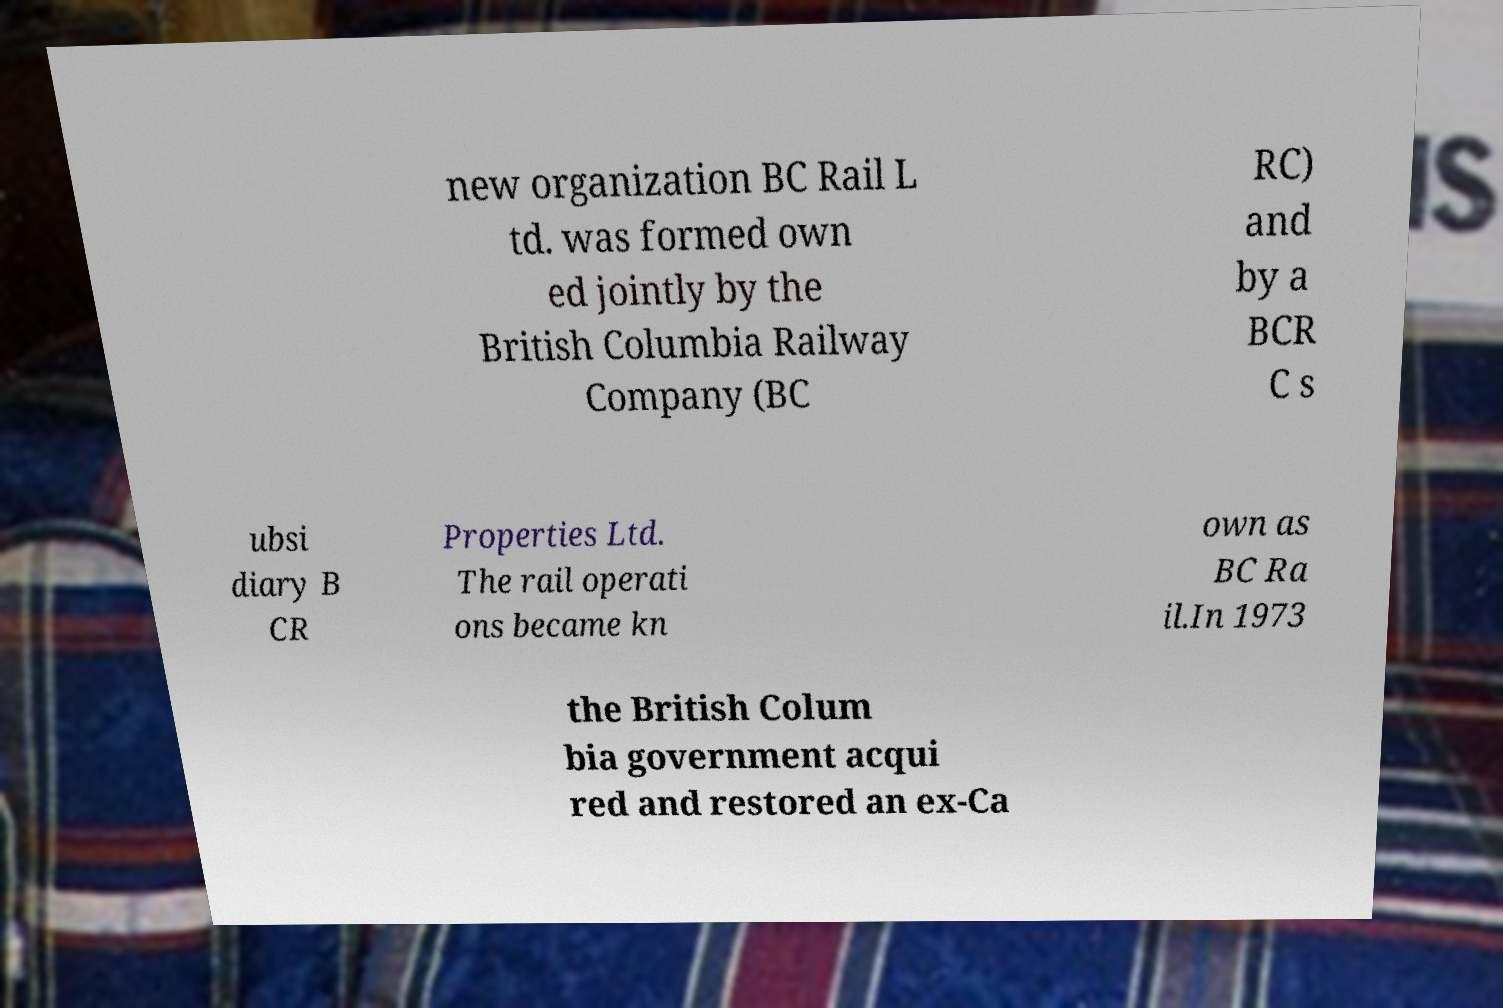Could you assist in decoding the text presented in this image and type it out clearly? new organization BC Rail L td. was formed own ed jointly by the British Columbia Railway Company (BC RC) and by a BCR C s ubsi diary B CR Properties Ltd. The rail operati ons became kn own as BC Ra il.In 1973 the British Colum bia government acqui red and restored an ex-Ca 